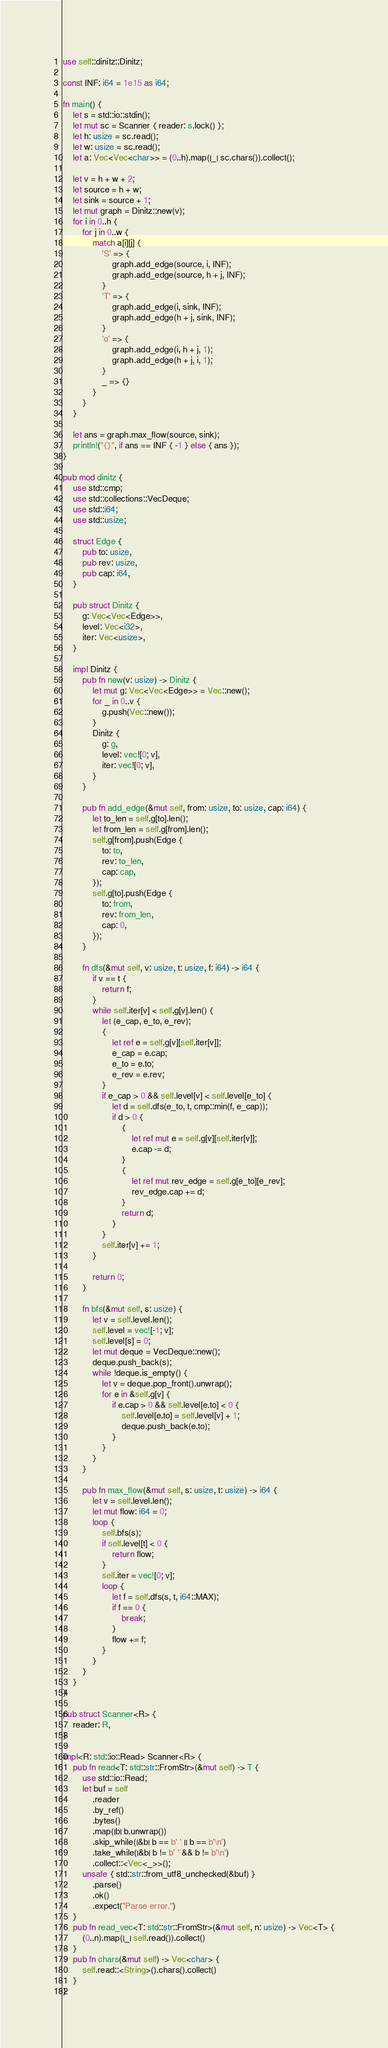Convert code to text. <code><loc_0><loc_0><loc_500><loc_500><_Rust_>use self::dinitz::Dinitz;

const INF: i64 = 1e15 as i64;

fn main() {
    let s = std::io::stdin();
    let mut sc = Scanner { reader: s.lock() };
    let h: usize = sc.read();
    let w: usize = sc.read();
    let a: Vec<Vec<char>> = (0..h).map(|_| sc.chars()).collect();

    let v = h + w + 2;
    let source = h + w;
    let sink = source + 1;
    let mut graph = Dinitz::new(v);
    for i in 0..h {
        for j in 0..w {
            match a[i][j] {
                'S' => {
                    graph.add_edge(source, i, INF);
                    graph.add_edge(source, h + j, INF);
                }
                'T' => {
                    graph.add_edge(i, sink, INF);
                    graph.add_edge(h + j, sink, INF);
                }
                'o' => {
                    graph.add_edge(i, h + j, 1);
                    graph.add_edge(h + j, i, 1);
                }
                _ => {}
            }
        }
    }

    let ans = graph.max_flow(source, sink);
    println!("{}", if ans == INF { -1 } else { ans });
}

pub mod dinitz {
    use std::cmp;
    use std::collections::VecDeque;
    use std::i64;
    use std::usize;

    struct Edge {
        pub to: usize,
        pub rev: usize,
        pub cap: i64,
    }

    pub struct Dinitz {
        g: Vec<Vec<Edge>>,
        level: Vec<i32>,
        iter: Vec<usize>,
    }

    impl Dinitz {
        pub fn new(v: usize) -> Dinitz {
            let mut g: Vec<Vec<Edge>> = Vec::new();
            for _ in 0..v {
                g.push(Vec::new());
            }
            Dinitz {
                g: g,
                level: vec![0; v],
                iter: vec![0; v],
            }
        }

        pub fn add_edge(&mut self, from: usize, to: usize, cap: i64) {
            let to_len = self.g[to].len();
            let from_len = self.g[from].len();
            self.g[from].push(Edge {
                to: to,
                rev: to_len,
                cap: cap,
            });
            self.g[to].push(Edge {
                to: from,
                rev: from_len,
                cap: 0,
            });
        }

        fn dfs(&mut self, v: usize, t: usize, f: i64) -> i64 {
            if v == t {
                return f;
            }
            while self.iter[v] < self.g[v].len() {
                let (e_cap, e_to, e_rev);
                {
                    let ref e = self.g[v][self.iter[v]];
                    e_cap = e.cap;
                    e_to = e.to;
                    e_rev = e.rev;
                }
                if e_cap > 0 && self.level[v] < self.level[e_to] {
                    let d = self.dfs(e_to, t, cmp::min(f, e_cap));
                    if d > 0 {
                        {
                            let ref mut e = self.g[v][self.iter[v]];
                            e.cap -= d;
                        }
                        {
                            let ref mut rev_edge = self.g[e_to][e_rev];
                            rev_edge.cap += d;
                        }
                        return d;
                    }
                }
                self.iter[v] += 1;
            }

            return 0;
        }

        fn bfs(&mut self, s: usize) {
            let v = self.level.len();
            self.level = vec![-1; v];
            self.level[s] = 0;
            let mut deque = VecDeque::new();
            deque.push_back(s);
            while !deque.is_empty() {
                let v = deque.pop_front().unwrap();
                for e in &self.g[v] {
                    if e.cap > 0 && self.level[e.to] < 0 {
                        self.level[e.to] = self.level[v] + 1;
                        deque.push_back(e.to);
                    }
                }
            }
        }

        pub fn max_flow(&mut self, s: usize, t: usize) -> i64 {
            let v = self.level.len();
            let mut flow: i64 = 0;
            loop {
                self.bfs(s);
                if self.level[t] < 0 {
                    return flow;
                }
                self.iter = vec![0; v];
                loop {
                    let f = self.dfs(s, t, i64::MAX);
                    if f == 0 {
                        break;
                    }
                    flow += f;
                }
            }
        }
    }
}

pub struct Scanner<R> {
    reader: R,
}

impl<R: std::io::Read> Scanner<R> {
    pub fn read<T: std::str::FromStr>(&mut self) -> T {
        use std::io::Read;
        let buf = self
            .reader
            .by_ref()
            .bytes()
            .map(|b| b.unwrap())
            .skip_while(|&b| b == b' ' || b == b'\n')
            .take_while(|&b| b != b' ' && b != b'\n')
            .collect::<Vec<_>>();
        unsafe { std::str::from_utf8_unchecked(&buf) }
            .parse()
            .ok()
            .expect("Parse error.")
    }
    pub fn read_vec<T: std::str::FromStr>(&mut self, n: usize) -> Vec<T> {
        (0..n).map(|_| self.read()).collect()
    }
    pub fn chars(&mut self) -> Vec<char> {
        self.read::<String>().chars().collect()
    }
}
</code> 